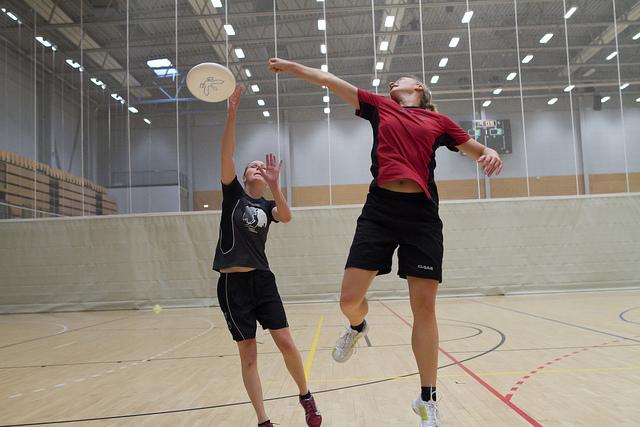What are they playing with?
Keep it brief. Frisbee. What is the man and woman reaching for in the air?
Quick response, please. Frisbee. Are they in a tennis center?
Quick response, please. No. 